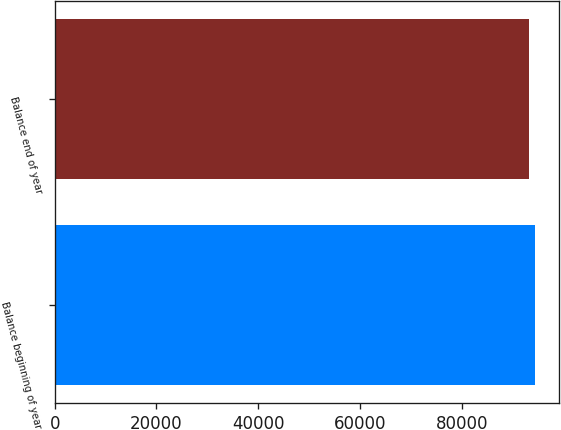Convert chart to OTSL. <chart><loc_0><loc_0><loc_500><loc_500><bar_chart><fcel>Balance beginning of year<fcel>Balance end of year<nl><fcel>94417<fcel>93192<nl></chart> 